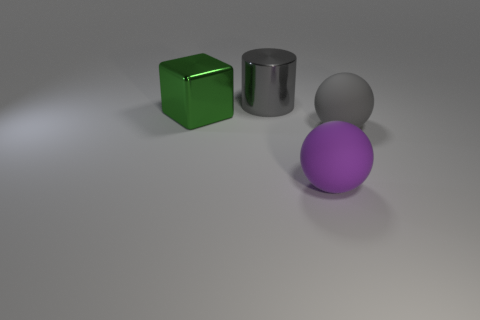Add 4 large gray spheres. How many objects exist? 8 Subtract 0 brown blocks. How many objects are left? 4 Subtract all cubes. How many objects are left? 3 Subtract 1 cubes. How many cubes are left? 0 Subtract all blue cylinders. Subtract all purple cubes. How many cylinders are left? 1 Subtract all large purple cubes. Subtract all large gray rubber things. How many objects are left? 3 Add 3 large gray spheres. How many large gray spheres are left? 4 Add 1 green shiny objects. How many green shiny objects exist? 2 Subtract all gray balls. How many balls are left? 1 